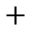Convert formula to latex. <formula><loc_0><loc_0><loc_500><loc_500>+</formula> 